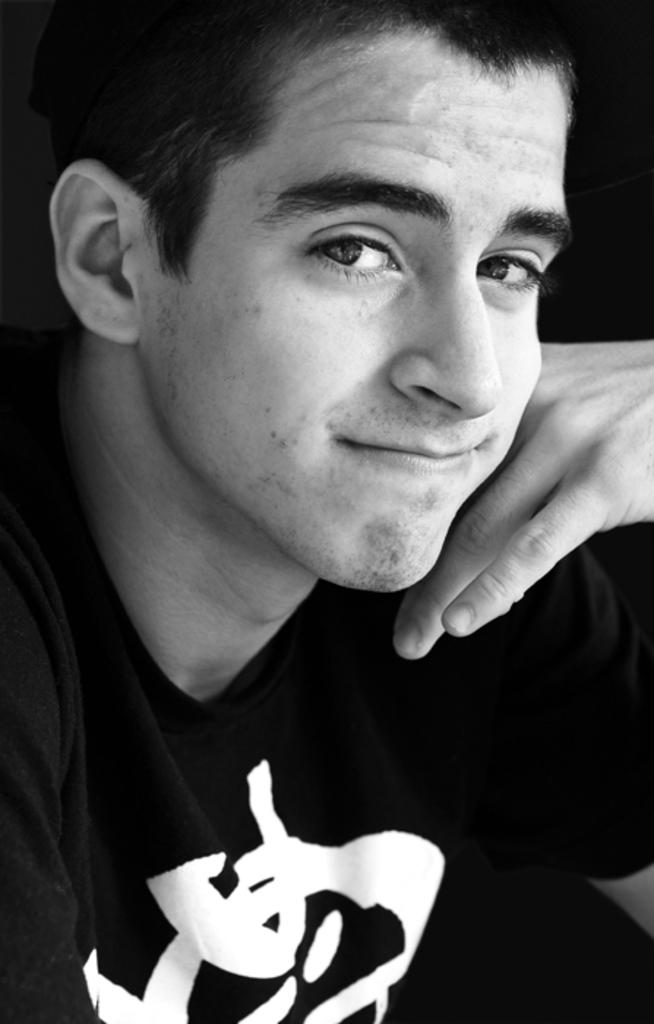What is the color scheme of the image? The image is black and white. Who is present in the image? There is a man in the image. What is the man wearing? The man is wearing a t-shirt. What is the man's facial expression in the image? The man is smiling. What is the man doing in the image? The man is giving a pose for the picture. What type of zinc is the man holding in the image? There is no zinc present in the image. How deep are the roots of the tree visible in the image? There is no tree or roots visible in the image; it features a man in a black and white setting. 